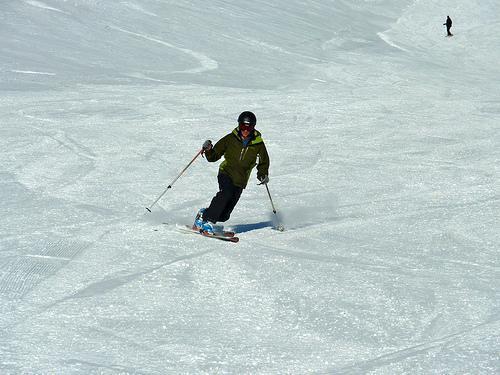How many people are there?
Give a very brief answer. 2. 